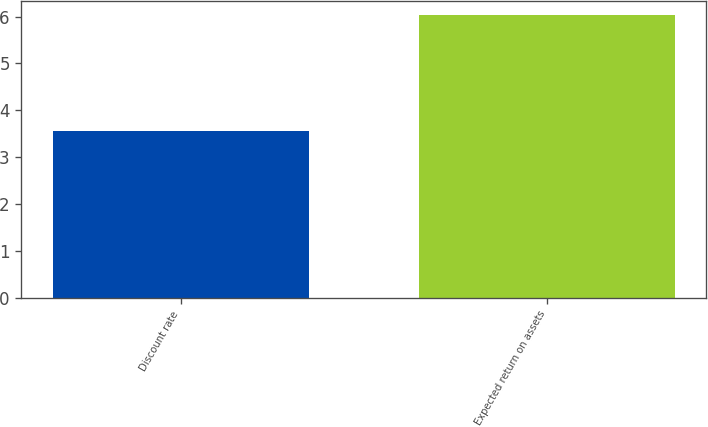<chart> <loc_0><loc_0><loc_500><loc_500><bar_chart><fcel>Discount rate<fcel>Expected return on assets<nl><fcel>3.56<fcel>6.03<nl></chart> 